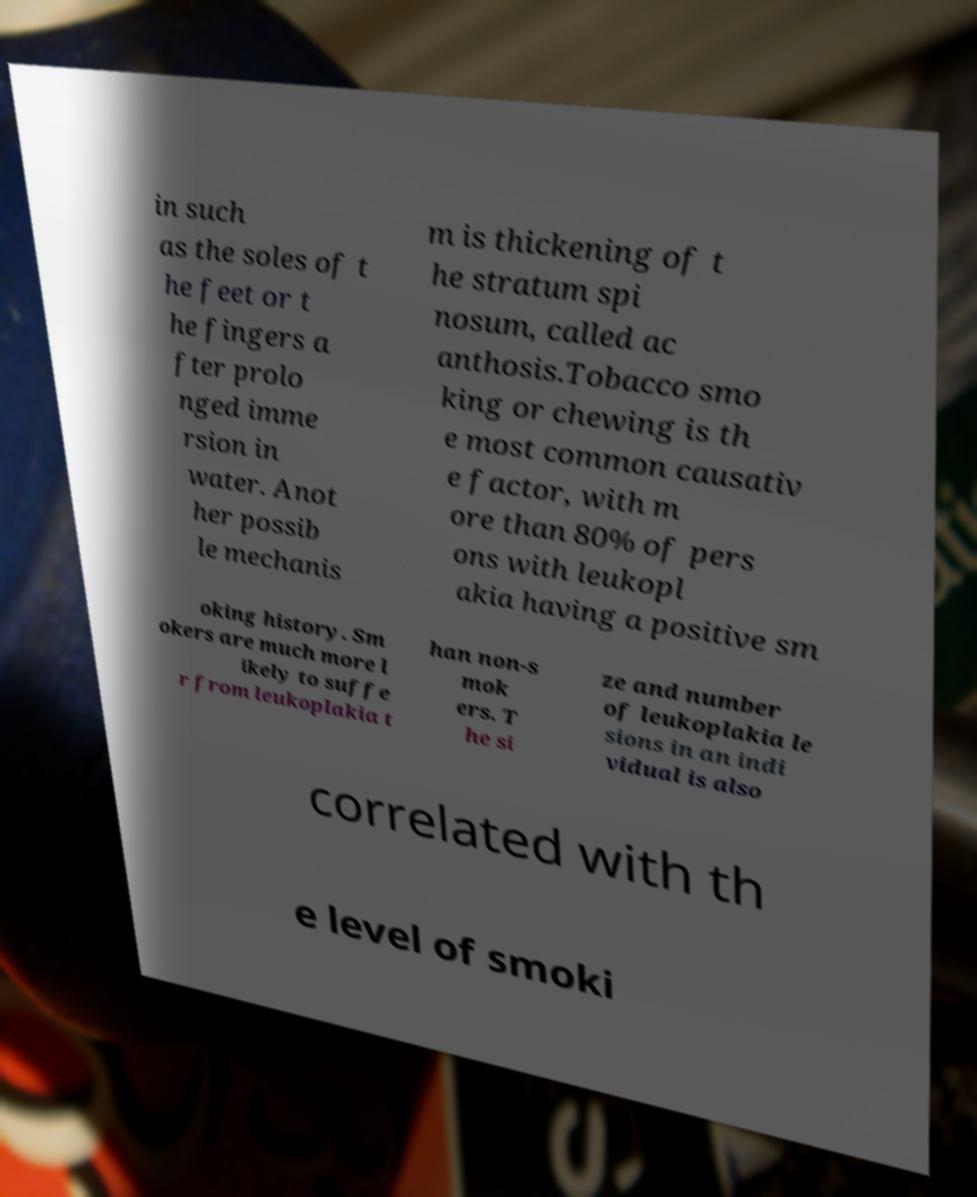Can you read and provide the text displayed in the image?This photo seems to have some interesting text. Can you extract and type it out for me? in such as the soles of t he feet or t he fingers a fter prolo nged imme rsion in water. Anot her possib le mechanis m is thickening of t he stratum spi nosum, called ac anthosis.Tobacco smo king or chewing is th e most common causativ e factor, with m ore than 80% of pers ons with leukopl akia having a positive sm oking history. Sm okers are much more l ikely to suffe r from leukoplakia t han non-s mok ers. T he si ze and number of leukoplakia le sions in an indi vidual is also correlated with th e level of smoki 